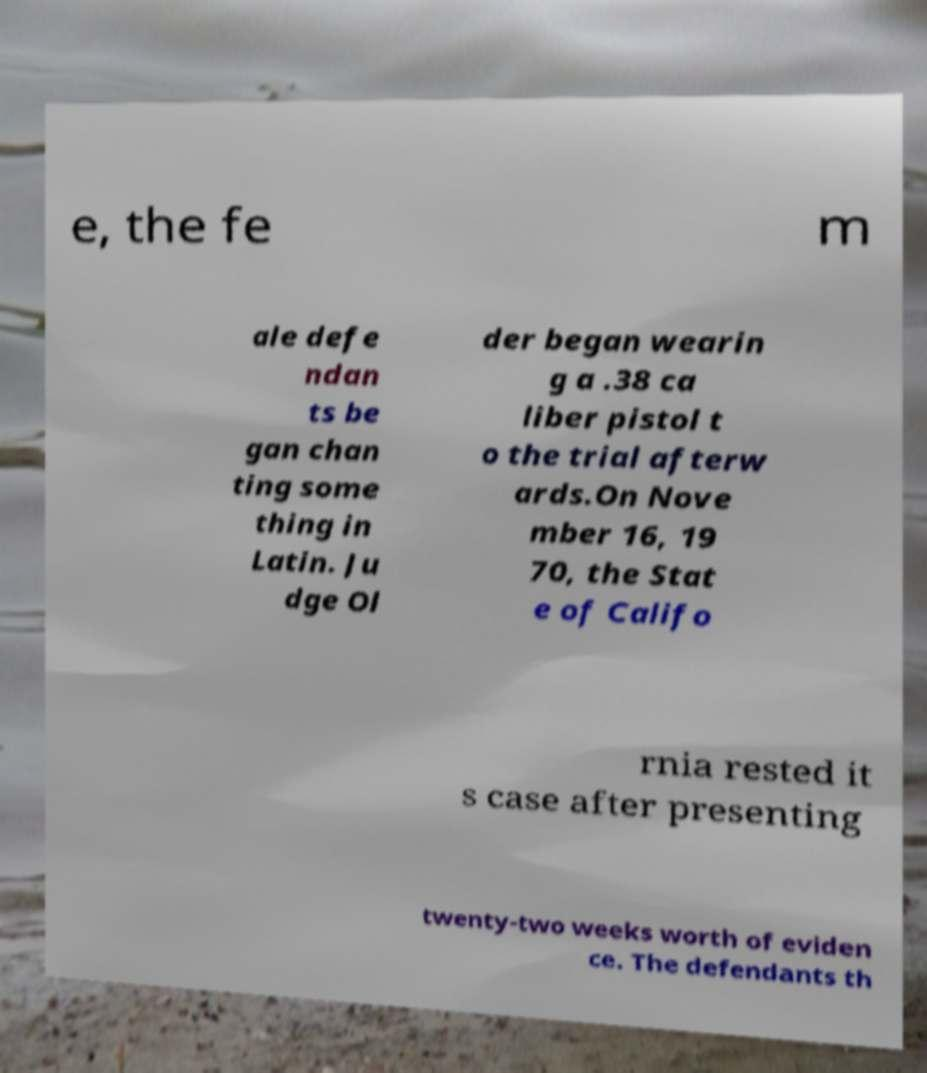Please read and relay the text visible in this image. What does it say? e, the fe m ale defe ndan ts be gan chan ting some thing in Latin. Ju dge Ol der began wearin g a .38 ca liber pistol t o the trial afterw ards.On Nove mber 16, 19 70, the Stat e of Califo rnia rested it s case after presenting twenty-two weeks worth of eviden ce. The defendants th 